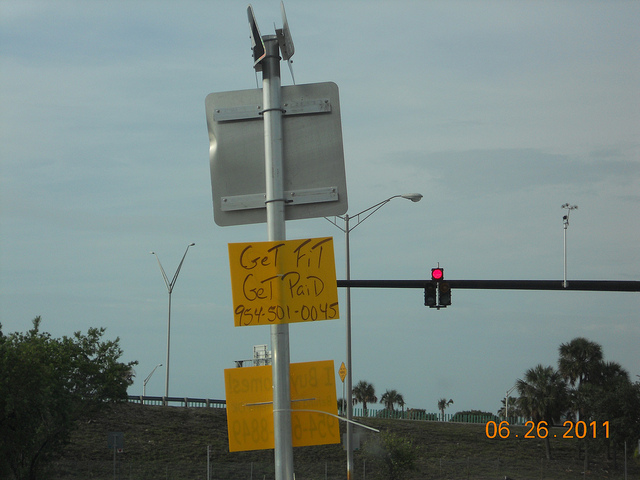<image>What occupation would use this for public safety? It's ambiguous what occupation would use this for public safety. It could be police, bus driver, or taxi. What occupation would use this for public safety? I don't know what occupation would use this for public safety. It can be police, cop, real estate, trainer, bus driver, taxi or weight trainer. 